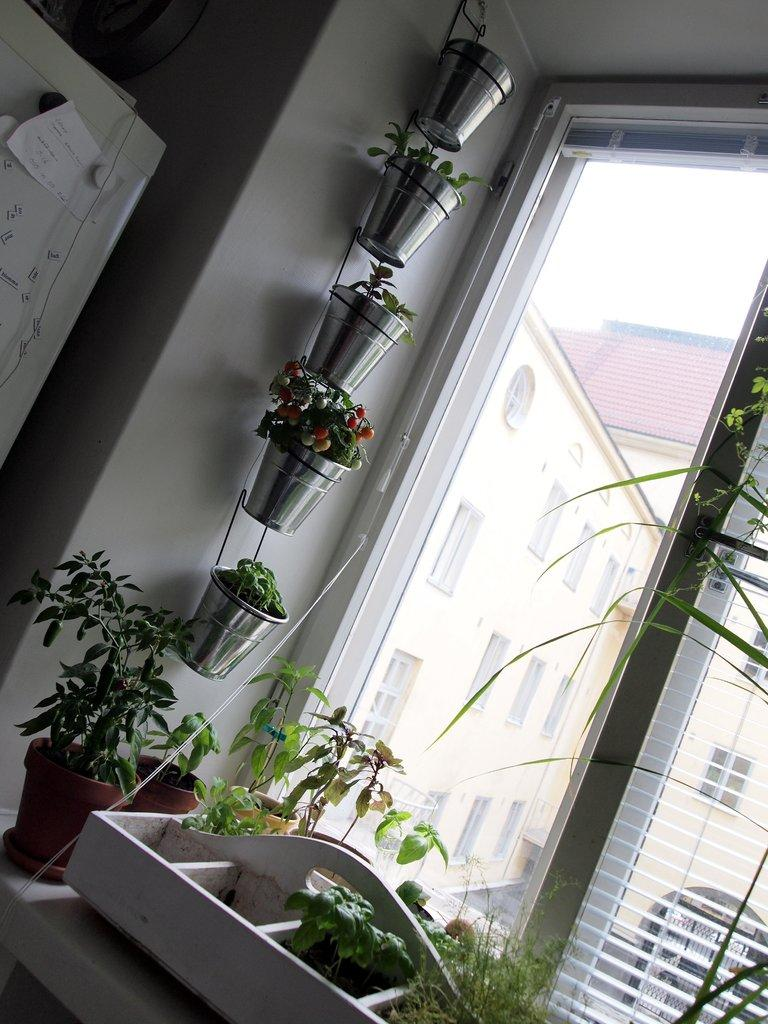What type of planter is present in the image? There is a metal pot planter in the image. What material is the wooden object made of? The wooden object is made of wood. Can you describe the planter in the image? There is a planter in the image. What is visible through the window in the image? There is a window in the image, and buildings are visible behind it. What type of marble is used to decorate the planter in the image? There is no marble present in the image; the planter is made of metal. Can you tell me how many friends are visible in the image? There are no people, including friends, present in the image. 